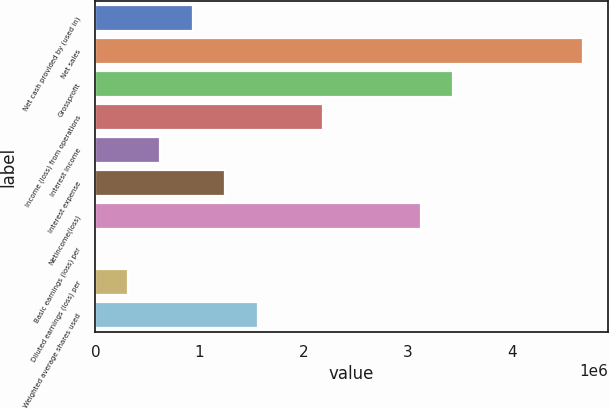Convert chart. <chart><loc_0><loc_0><loc_500><loc_500><bar_chart><fcel>Net cash provided by (used in)<fcel>Net sales<fcel>Grossprofit<fcel>Income (loss) from operations<fcel>Interest income<fcel>Interest expense<fcel>Netincome(loss)<fcel>Basic earnings (loss) per<fcel>Diluted earnings (loss) per<fcel>Weighted average shares used<nl><fcel>936731<fcel>4.68365e+06<fcel>3.43468e+06<fcel>2.1857e+06<fcel>624488<fcel>1.24897e+06<fcel>3.12243e+06<fcel>1.56<fcel>312245<fcel>1.56122e+06<nl></chart> 